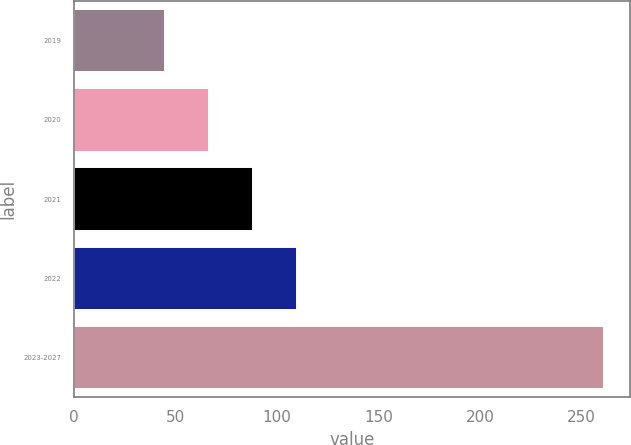Convert chart. <chart><loc_0><loc_0><loc_500><loc_500><bar_chart><fcel>2019<fcel>2020<fcel>2021<fcel>2022<fcel>2023-2027<nl><fcel>45<fcel>66.6<fcel>88.2<fcel>109.8<fcel>261<nl></chart> 